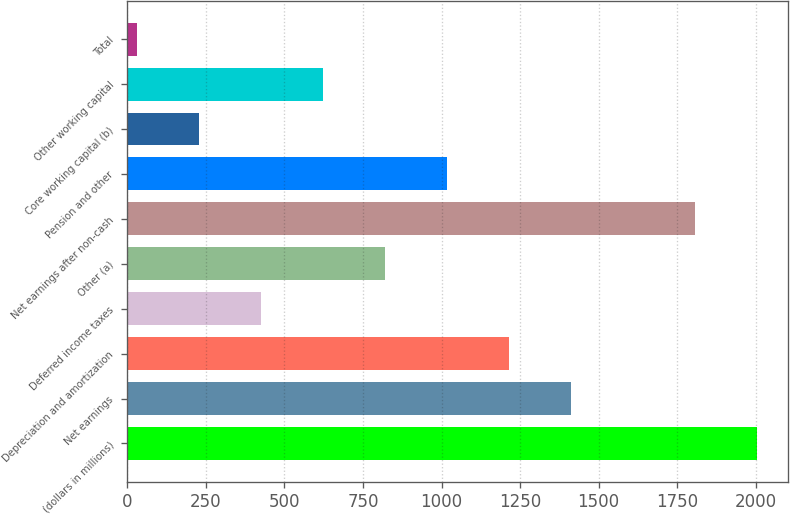<chart> <loc_0><loc_0><loc_500><loc_500><bar_chart><fcel>(dollars in millions)<fcel>Net earnings<fcel>Depreciation and amortization<fcel>Deferred income taxes<fcel>Other (a)<fcel>Net earnings after non-cash<fcel>Pension and other<fcel>Core working capital (b)<fcel>Other working capital<fcel>Total<nl><fcel>2004<fcel>1411.74<fcel>1214.32<fcel>424.64<fcel>819.48<fcel>1806.58<fcel>1016.9<fcel>227.22<fcel>622.06<fcel>29.8<nl></chart> 